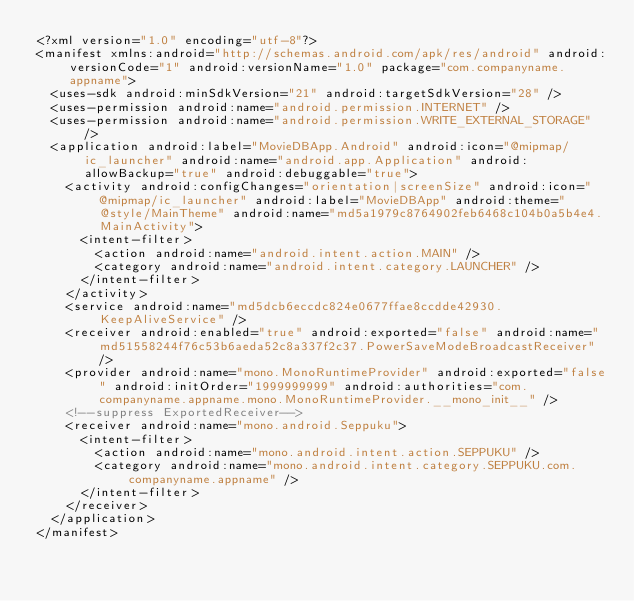Convert code to text. <code><loc_0><loc_0><loc_500><loc_500><_XML_><?xml version="1.0" encoding="utf-8"?>
<manifest xmlns:android="http://schemas.android.com/apk/res/android" android:versionCode="1" android:versionName="1.0" package="com.companyname.appname">
  <uses-sdk android:minSdkVersion="21" android:targetSdkVersion="28" />
  <uses-permission android:name="android.permission.INTERNET" />
  <uses-permission android:name="android.permission.WRITE_EXTERNAL_STORAGE" />
  <application android:label="MovieDBApp.Android" android:icon="@mipmap/ic_launcher" android:name="android.app.Application" android:allowBackup="true" android:debuggable="true">
    <activity android:configChanges="orientation|screenSize" android:icon="@mipmap/ic_launcher" android:label="MovieDBApp" android:theme="@style/MainTheme" android:name="md5a1979c8764902feb6468c104b0a5b4e4.MainActivity">
      <intent-filter>
        <action android:name="android.intent.action.MAIN" />
        <category android:name="android.intent.category.LAUNCHER" />
      </intent-filter>
    </activity>
    <service android:name="md5dcb6eccdc824e0677ffae8ccdde42930.KeepAliveService" />
    <receiver android:enabled="true" android:exported="false" android:name="md51558244f76c53b6aeda52c8a337f2c37.PowerSaveModeBroadcastReceiver" />
    <provider android:name="mono.MonoRuntimeProvider" android:exported="false" android:initOrder="1999999999" android:authorities="com.companyname.appname.mono.MonoRuntimeProvider.__mono_init__" />
    <!--suppress ExportedReceiver-->
    <receiver android:name="mono.android.Seppuku">
      <intent-filter>
        <action android:name="mono.android.intent.action.SEPPUKU" />
        <category android:name="mono.android.intent.category.SEPPUKU.com.companyname.appname" />
      </intent-filter>
    </receiver>
  </application>
</manifest></code> 